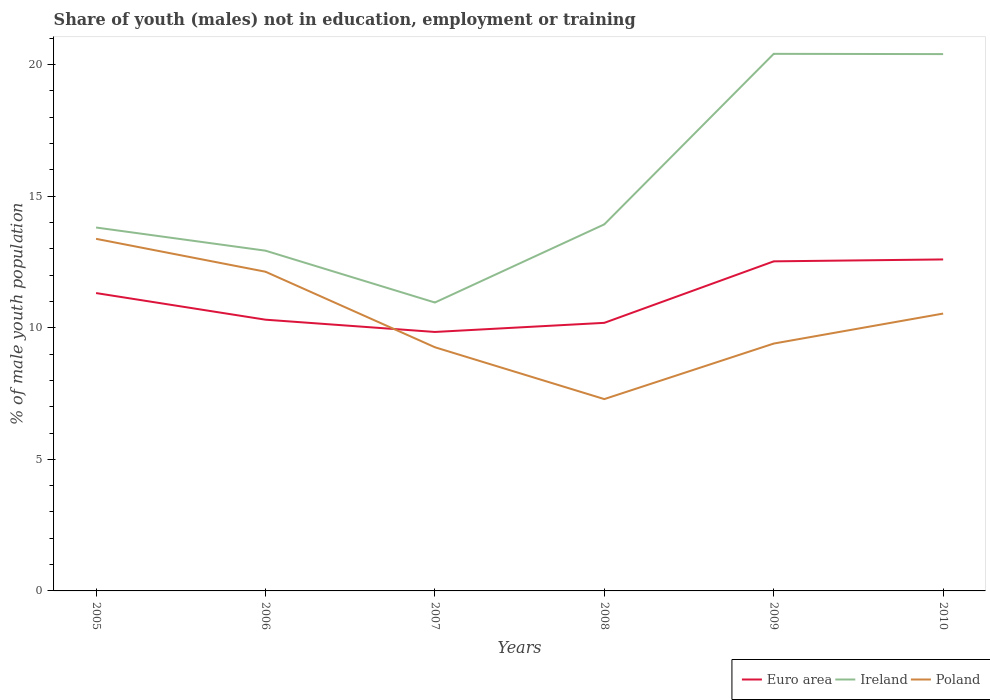Does the line corresponding to Euro area intersect with the line corresponding to Poland?
Offer a very short reply. Yes. Is the number of lines equal to the number of legend labels?
Offer a terse response. Yes. Across all years, what is the maximum percentage of unemployed males population in in Poland?
Make the answer very short. 7.29. In which year was the percentage of unemployed males population in in Euro area maximum?
Make the answer very short. 2007. What is the total percentage of unemployed males population in in Euro area in the graph?
Your answer should be compact. -0.07. What is the difference between the highest and the second highest percentage of unemployed males population in in Poland?
Your answer should be very brief. 6.09. What is the difference between the highest and the lowest percentage of unemployed males population in in Poland?
Provide a succinct answer. 3. How many years are there in the graph?
Provide a short and direct response. 6. What is the difference between two consecutive major ticks on the Y-axis?
Provide a short and direct response. 5. Where does the legend appear in the graph?
Your response must be concise. Bottom right. How are the legend labels stacked?
Your response must be concise. Horizontal. What is the title of the graph?
Give a very brief answer. Share of youth (males) not in education, employment or training. Does "Ethiopia" appear as one of the legend labels in the graph?
Keep it short and to the point. No. What is the label or title of the Y-axis?
Your response must be concise. % of male youth population. What is the % of male youth population of Euro area in 2005?
Offer a terse response. 11.32. What is the % of male youth population of Ireland in 2005?
Ensure brevity in your answer.  13.81. What is the % of male youth population in Poland in 2005?
Your answer should be very brief. 13.38. What is the % of male youth population in Euro area in 2006?
Give a very brief answer. 10.31. What is the % of male youth population in Ireland in 2006?
Your answer should be very brief. 12.93. What is the % of male youth population of Poland in 2006?
Keep it short and to the point. 12.13. What is the % of male youth population in Euro area in 2007?
Your response must be concise. 9.84. What is the % of male youth population of Ireland in 2007?
Your response must be concise. 10.96. What is the % of male youth population of Poland in 2007?
Offer a very short reply. 9.26. What is the % of male youth population in Euro area in 2008?
Your answer should be very brief. 10.19. What is the % of male youth population in Ireland in 2008?
Your response must be concise. 13.93. What is the % of male youth population in Poland in 2008?
Ensure brevity in your answer.  7.29. What is the % of male youth population of Euro area in 2009?
Offer a very short reply. 12.52. What is the % of male youth population of Ireland in 2009?
Offer a very short reply. 20.41. What is the % of male youth population in Poland in 2009?
Provide a succinct answer. 9.4. What is the % of male youth population of Euro area in 2010?
Provide a succinct answer. 12.6. What is the % of male youth population of Ireland in 2010?
Make the answer very short. 20.4. What is the % of male youth population in Poland in 2010?
Your answer should be very brief. 10.54. Across all years, what is the maximum % of male youth population in Euro area?
Your answer should be very brief. 12.6. Across all years, what is the maximum % of male youth population of Ireland?
Your answer should be very brief. 20.41. Across all years, what is the maximum % of male youth population in Poland?
Your response must be concise. 13.38. Across all years, what is the minimum % of male youth population in Euro area?
Ensure brevity in your answer.  9.84. Across all years, what is the minimum % of male youth population of Ireland?
Your answer should be compact. 10.96. Across all years, what is the minimum % of male youth population in Poland?
Offer a very short reply. 7.29. What is the total % of male youth population of Euro area in the graph?
Offer a terse response. 66.78. What is the total % of male youth population in Ireland in the graph?
Offer a terse response. 92.44. What is the difference between the % of male youth population of Euro area in 2005 and that in 2006?
Your answer should be compact. 1.01. What is the difference between the % of male youth population in Poland in 2005 and that in 2006?
Keep it short and to the point. 1.25. What is the difference between the % of male youth population in Euro area in 2005 and that in 2007?
Provide a short and direct response. 1.48. What is the difference between the % of male youth population of Ireland in 2005 and that in 2007?
Ensure brevity in your answer.  2.85. What is the difference between the % of male youth population of Poland in 2005 and that in 2007?
Provide a short and direct response. 4.12. What is the difference between the % of male youth population in Euro area in 2005 and that in 2008?
Provide a succinct answer. 1.13. What is the difference between the % of male youth population in Ireland in 2005 and that in 2008?
Offer a terse response. -0.12. What is the difference between the % of male youth population of Poland in 2005 and that in 2008?
Ensure brevity in your answer.  6.09. What is the difference between the % of male youth population in Euro area in 2005 and that in 2009?
Provide a succinct answer. -1.21. What is the difference between the % of male youth population of Ireland in 2005 and that in 2009?
Your answer should be compact. -6.6. What is the difference between the % of male youth population of Poland in 2005 and that in 2009?
Your response must be concise. 3.98. What is the difference between the % of male youth population of Euro area in 2005 and that in 2010?
Provide a succinct answer. -1.28. What is the difference between the % of male youth population of Ireland in 2005 and that in 2010?
Your answer should be very brief. -6.59. What is the difference between the % of male youth population of Poland in 2005 and that in 2010?
Keep it short and to the point. 2.84. What is the difference between the % of male youth population of Euro area in 2006 and that in 2007?
Your answer should be compact. 0.47. What is the difference between the % of male youth population in Ireland in 2006 and that in 2007?
Provide a succinct answer. 1.97. What is the difference between the % of male youth population of Poland in 2006 and that in 2007?
Offer a terse response. 2.87. What is the difference between the % of male youth population of Euro area in 2006 and that in 2008?
Ensure brevity in your answer.  0.12. What is the difference between the % of male youth population in Poland in 2006 and that in 2008?
Ensure brevity in your answer.  4.84. What is the difference between the % of male youth population of Euro area in 2006 and that in 2009?
Provide a succinct answer. -2.22. What is the difference between the % of male youth population of Ireland in 2006 and that in 2009?
Ensure brevity in your answer.  -7.48. What is the difference between the % of male youth population in Poland in 2006 and that in 2009?
Your answer should be compact. 2.73. What is the difference between the % of male youth population in Euro area in 2006 and that in 2010?
Offer a terse response. -2.29. What is the difference between the % of male youth population in Ireland in 2006 and that in 2010?
Offer a terse response. -7.47. What is the difference between the % of male youth population of Poland in 2006 and that in 2010?
Your answer should be very brief. 1.59. What is the difference between the % of male youth population in Euro area in 2007 and that in 2008?
Provide a succinct answer. -0.35. What is the difference between the % of male youth population of Ireland in 2007 and that in 2008?
Your answer should be compact. -2.97. What is the difference between the % of male youth population in Poland in 2007 and that in 2008?
Offer a very short reply. 1.97. What is the difference between the % of male youth population in Euro area in 2007 and that in 2009?
Keep it short and to the point. -2.68. What is the difference between the % of male youth population in Ireland in 2007 and that in 2009?
Offer a terse response. -9.45. What is the difference between the % of male youth population of Poland in 2007 and that in 2009?
Keep it short and to the point. -0.14. What is the difference between the % of male youth population in Euro area in 2007 and that in 2010?
Offer a terse response. -2.76. What is the difference between the % of male youth population in Ireland in 2007 and that in 2010?
Your answer should be compact. -9.44. What is the difference between the % of male youth population of Poland in 2007 and that in 2010?
Offer a very short reply. -1.28. What is the difference between the % of male youth population in Euro area in 2008 and that in 2009?
Your answer should be very brief. -2.34. What is the difference between the % of male youth population of Ireland in 2008 and that in 2009?
Your answer should be very brief. -6.48. What is the difference between the % of male youth population in Poland in 2008 and that in 2009?
Provide a short and direct response. -2.11. What is the difference between the % of male youth population in Euro area in 2008 and that in 2010?
Give a very brief answer. -2.41. What is the difference between the % of male youth population in Ireland in 2008 and that in 2010?
Provide a short and direct response. -6.47. What is the difference between the % of male youth population in Poland in 2008 and that in 2010?
Offer a very short reply. -3.25. What is the difference between the % of male youth population in Euro area in 2009 and that in 2010?
Offer a terse response. -0.07. What is the difference between the % of male youth population of Ireland in 2009 and that in 2010?
Your answer should be very brief. 0.01. What is the difference between the % of male youth population in Poland in 2009 and that in 2010?
Provide a succinct answer. -1.14. What is the difference between the % of male youth population in Euro area in 2005 and the % of male youth population in Ireland in 2006?
Keep it short and to the point. -1.61. What is the difference between the % of male youth population of Euro area in 2005 and the % of male youth population of Poland in 2006?
Your answer should be compact. -0.81. What is the difference between the % of male youth population in Ireland in 2005 and the % of male youth population in Poland in 2006?
Offer a very short reply. 1.68. What is the difference between the % of male youth population of Euro area in 2005 and the % of male youth population of Ireland in 2007?
Offer a terse response. 0.36. What is the difference between the % of male youth population in Euro area in 2005 and the % of male youth population in Poland in 2007?
Offer a very short reply. 2.06. What is the difference between the % of male youth population in Ireland in 2005 and the % of male youth population in Poland in 2007?
Keep it short and to the point. 4.55. What is the difference between the % of male youth population of Euro area in 2005 and the % of male youth population of Ireland in 2008?
Keep it short and to the point. -2.61. What is the difference between the % of male youth population of Euro area in 2005 and the % of male youth population of Poland in 2008?
Provide a short and direct response. 4.03. What is the difference between the % of male youth population in Ireland in 2005 and the % of male youth population in Poland in 2008?
Provide a short and direct response. 6.52. What is the difference between the % of male youth population in Euro area in 2005 and the % of male youth population in Ireland in 2009?
Make the answer very short. -9.09. What is the difference between the % of male youth population in Euro area in 2005 and the % of male youth population in Poland in 2009?
Your response must be concise. 1.92. What is the difference between the % of male youth population of Ireland in 2005 and the % of male youth population of Poland in 2009?
Give a very brief answer. 4.41. What is the difference between the % of male youth population in Euro area in 2005 and the % of male youth population in Ireland in 2010?
Your answer should be compact. -9.08. What is the difference between the % of male youth population in Euro area in 2005 and the % of male youth population in Poland in 2010?
Offer a very short reply. 0.78. What is the difference between the % of male youth population in Ireland in 2005 and the % of male youth population in Poland in 2010?
Your response must be concise. 3.27. What is the difference between the % of male youth population of Euro area in 2006 and the % of male youth population of Ireland in 2007?
Give a very brief answer. -0.65. What is the difference between the % of male youth population in Euro area in 2006 and the % of male youth population in Poland in 2007?
Provide a short and direct response. 1.05. What is the difference between the % of male youth population of Ireland in 2006 and the % of male youth population of Poland in 2007?
Your answer should be very brief. 3.67. What is the difference between the % of male youth population of Euro area in 2006 and the % of male youth population of Ireland in 2008?
Your response must be concise. -3.62. What is the difference between the % of male youth population of Euro area in 2006 and the % of male youth population of Poland in 2008?
Give a very brief answer. 3.02. What is the difference between the % of male youth population in Ireland in 2006 and the % of male youth population in Poland in 2008?
Your answer should be compact. 5.64. What is the difference between the % of male youth population in Euro area in 2006 and the % of male youth population in Ireland in 2009?
Provide a short and direct response. -10.1. What is the difference between the % of male youth population in Euro area in 2006 and the % of male youth population in Poland in 2009?
Your answer should be very brief. 0.91. What is the difference between the % of male youth population in Ireland in 2006 and the % of male youth population in Poland in 2009?
Provide a short and direct response. 3.53. What is the difference between the % of male youth population in Euro area in 2006 and the % of male youth population in Ireland in 2010?
Provide a short and direct response. -10.09. What is the difference between the % of male youth population in Euro area in 2006 and the % of male youth population in Poland in 2010?
Your response must be concise. -0.23. What is the difference between the % of male youth population in Ireland in 2006 and the % of male youth population in Poland in 2010?
Your answer should be very brief. 2.39. What is the difference between the % of male youth population of Euro area in 2007 and the % of male youth population of Ireland in 2008?
Make the answer very short. -4.09. What is the difference between the % of male youth population of Euro area in 2007 and the % of male youth population of Poland in 2008?
Provide a short and direct response. 2.55. What is the difference between the % of male youth population in Ireland in 2007 and the % of male youth population in Poland in 2008?
Make the answer very short. 3.67. What is the difference between the % of male youth population of Euro area in 2007 and the % of male youth population of Ireland in 2009?
Ensure brevity in your answer.  -10.57. What is the difference between the % of male youth population in Euro area in 2007 and the % of male youth population in Poland in 2009?
Keep it short and to the point. 0.44. What is the difference between the % of male youth population in Ireland in 2007 and the % of male youth population in Poland in 2009?
Provide a succinct answer. 1.56. What is the difference between the % of male youth population in Euro area in 2007 and the % of male youth population in Ireland in 2010?
Provide a succinct answer. -10.56. What is the difference between the % of male youth population of Euro area in 2007 and the % of male youth population of Poland in 2010?
Your response must be concise. -0.7. What is the difference between the % of male youth population of Ireland in 2007 and the % of male youth population of Poland in 2010?
Your response must be concise. 0.42. What is the difference between the % of male youth population of Euro area in 2008 and the % of male youth population of Ireland in 2009?
Give a very brief answer. -10.22. What is the difference between the % of male youth population in Euro area in 2008 and the % of male youth population in Poland in 2009?
Your answer should be compact. 0.79. What is the difference between the % of male youth population in Ireland in 2008 and the % of male youth population in Poland in 2009?
Offer a terse response. 4.53. What is the difference between the % of male youth population in Euro area in 2008 and the % of male youth population in Ireland in 2010?
Offer a terse response. -10.21. What is the difference between the % of male youth population of Euro area in 2008 and the % of male youth population of Poland in 2010?
Make the answer very short. -0.35. What is the difference between the % of male youth population in Ireland in 2008 and the % of male youth population in Poland in 2010?
Provide a short and direct response. 3.39. What is the difference between the % of male youth population of Euro area in 2009 and the % of male youth population of Ireland in 2010?
Ensure brevity in your answer.  -7.88. What is the difference between the % of male youth population in Euro area in 2009 and the % of male youth population in Poland in 2010?
Make the answer very short. 1.98. What is the difference between the % of male youth population of Ireland in 2009 and the % of male youth population of Poland in 2010?
Offer a terse response. 9.87. What is the average % of male youth population of Euro area per year?
Your answer should be very brief. 11.13. What is the average % of male youth population of Ireland per year?
Your answer should be compact. 15.41. What is the average % of male youth population in Poland per year?
Provide a succinct answer. 10.33. In the year 2005, what is the difference between the % of male youth population of Euro area and % of male youth population of Ireland?
Make the answer very short. -2.49. In the year 2005, what is the difference between the % of male youth population of Euro area and % of male youth population of Poland?
Your answer should be very brief. -2.06. In the year 2005, what is the difference between the % of male youth population in Ireland and % of male youth population in Poland?
Your answer should be very brief. 0.43. In the year 2006, what is the difference between the % of male youth population in Euro area and % of male youth population in Ireland?
Provide a succinct answer. -2.62. In the year 2006, what is the difference between the % of male youth population in Euro area and % of male youth population in Poland?
Your answer should be very brief. -1.82. In the year 2007, what is the difference between the % of male youth population of Euro area and % of male youth population of Ireland?
Your answer should be compact. -1.12. In the year 2007, what is the difference between the % of male youth population of Euro area and % of male youth population of Poland?
Your response must be concise. 0.58. In the year 2008, what is the difference between the % of male youth population of Euro area and % of male youth population of Ireland?
Offer a terse response. -3.74. In the year 2008, what is the difference between the % of male youth population in Euro area and % of male youth population in Poland?
Make the answer very short. 2.9. In the year 2008, what is the difference between the % of male youth population in Ireland and % of male youth population in Poland?
Your response must be concise. 6.64. In the year 2009, what is the difference between the % of male youth population of Euro area and % of male youth population of Ireland?
Your response must be concise. -7.89. In the year 2009, what is the difference between the % of male youth population of Euro area and % of male youth population of Poland?
Offer a very short reply. 3.12. In the year 2009, what is the difference between the % of male youth population in Ireland and % of male youth population in Poland?
Offer a very short reply. 11.01. In the year 2010, what is the difference between the % of male youth population of Euro area and % of male youth population of Ireland?
Ensure brevity in your answer.  -7.8. In the year 2010, what is the difference between the % of male youth population of Euro area and % of male youth population of Poland?
Provide a succinct answer. 2.06. In the year 2010, what is the difference between the % of male youth population of Ireland and % of male youth population of Poland?
Offer a terse response. 9.86. What is the ratio of the % of male youth population of Euro area in 2005 to that in 2006?
Keep it short and to the point. 1.1. What is the ratio of the % of male youth population of Ireland in 2005 to that in 2006?
Your answer should be compact. 1.07. What is the ratio of the % of male youth population of Poland in 2005 to that in 2006?
Keep it short and to the point. 1.1. What is the ratio of the % of male youth population of Euro area in 2005 to that in 2007?
Ensure brevity in your answer.  1.15. What is the ratio of the % of male youth population of Ireland in 2005 to that in 2007?
Keep it short and to the point. 1.26. What is the ratio of the % of male youth population in Poland in 2005 to that in 2007?
Provide a succinct answer. 1.44. What is the ratio of the % of male youth population in Poland in 2005 to that in 2008?
Provide a short and direct response. 1.84. What is the ratio of the % of male youth population of Euro area in 2005 to that in 2009?
Provide a succinct answer. 0.9. What is the ratio of the % of male youth population of Ireland in 2005 to that in 2009?
Your answer should be very brief. 0.68. What is the ratio of the % of male youth population in Poland in 2005 to that in 2009?
Your response must be concise. 1.42. What is the ratio of the % of male youth population of Euro area in 2005 to that in 2010?
Ensure brevity in your answer.  0.9. What is the ratio of the % of male youth population of Ireland in 2005 to that in 2010?
Give a very brief answer. 0.68. What is the ratio of the % of male youth population of Poland in 2005 to that in 2010?
Provide a succinct answer. 1.27. What is the ratio of the % of male youth population in Euro area in 2006 to that in 2007?
Your response must be concise. 1.05. What is the ratio of the % of male youth population in Ireland in 2006 to that in 2007?
Your response must be concise. 1.18. What is the ratio of the % of male youth population of Poland in 2006 to that in 2007?
Your response must be concise. 1.31. What is the ratio of the % of male youth population in Euro area in 2006 to that in 2008?
Keep it short and to the point. 1.01. What is the ratio of the % of male youth population of Ireland in 2006 to that in 2008?
Your response must be concise. 0.93. What is the ratio of the % of male youth population in Poland in 2006 to that in 2008?
Keep it short and to the point. 1.66. What is the ratio of the % of male youth population in Euro area in 2006 to that in 2009?
Ensure brevity in your answer.  0.82. What is the ratio of the % of male youth population in Ireland in 2006 to that in 2009?
Your answer should be compact. 0.63. What is the ratio of the % of male youth population of Poland in 2006 to that in 2009?
Offer a terse response. 1.29. What is the ratio of the % of male youth population in Euro area in 2006 to that in 2010?
Your answer should be compact. 0.82. What is the ratio of the % of male youth population in Ireland in 2006 to that in 2010?
Make the answer very short. 0.63. What is the ratio of the % of male youth population in Poland in 2006 to that in 2010?
Ensure brevity in your answer.  1.15. What is the ratio of the % of male youth population in Euro area in 2007 to that in 2008?
Ensure brevity in your answer.  0.97. What is the ratio of the % of male youth population of Ireland in 2007 to that in 2008?
Your answer should be compact. 0.79. What is the ratio of the % of male youth population of Poland in 2007 to that in 2008?
Ensure brevity in your answer.  1.27. What is the ratio of the % of male youth population in Euro area in 2007 to that in 2009?
Ensure brevity in your answer.  0.79. What is the ratio of the % of male youth population of Ireland in 2007 to that in 2009?
Your answer should be very brief. 0.54. What is the ratio of the % of male youth population of Poland in 2007 to that in 2009?
Give a very brief answer. 0.99. What is the ratio of the % of male youth population of Euro area in 2007 to that in 2010?
Provide a short and direct response. 0.78. What is the ratio of the % of male youth population in Ireland in 2007 to that in 2010?
Give a very brief answer. 0.54. What is the ratio of the % of male youth population in Poland in 2007 to that in 2010?
Make the answer very short. 0.88. What is the ratio of the % of male youth population in Euro area in 2008 to that in 2009?
Provide a succinct answer. 0.81. What is the ratio of the % of male youth population in Ireland in 2008 to that in 2009?
Provide a succinct answer. 0.68. What is the ratio of the % of male youth population in Poland in 2008 to that in 2009?
Provide a short and direct response. 0.78. What is the ratio of the % of male youth population of Euro area in 2008 to that in 2010?
Your answer should be very brief. 0.81. What is the ratio of the % of male youth population in Ireland in 2008 to that in 2010?
Offer a terse response. 0.68. What is the ratio of the % of male youth population of Poland in 2008 to that in 2010?
Provide a short and direct response. 0.69. What is the ratio of the % of male youth population in Poland in 2009 to that in 2010?
Ensure brevity in your answer.  0.89. What is the difference between the highest and the second highest % of male youth population of Euro area?
Your response must be concise. 0.07. What is the difference between the highest and the second highest % of male youth population in Ireland?
Ensure brevity in your answer.  0.01. What is the difference between the highest and the lowest % of male youth population of Euro area?
Your response must be concise. 2.76. What is the difference between the highest and the lowest % of male youth population in Ireland?
Offer a terse response. 9.45. What is the difference between the highest and the lowest % of male youth population in Poland?
Your response must be concise. 6.09. 